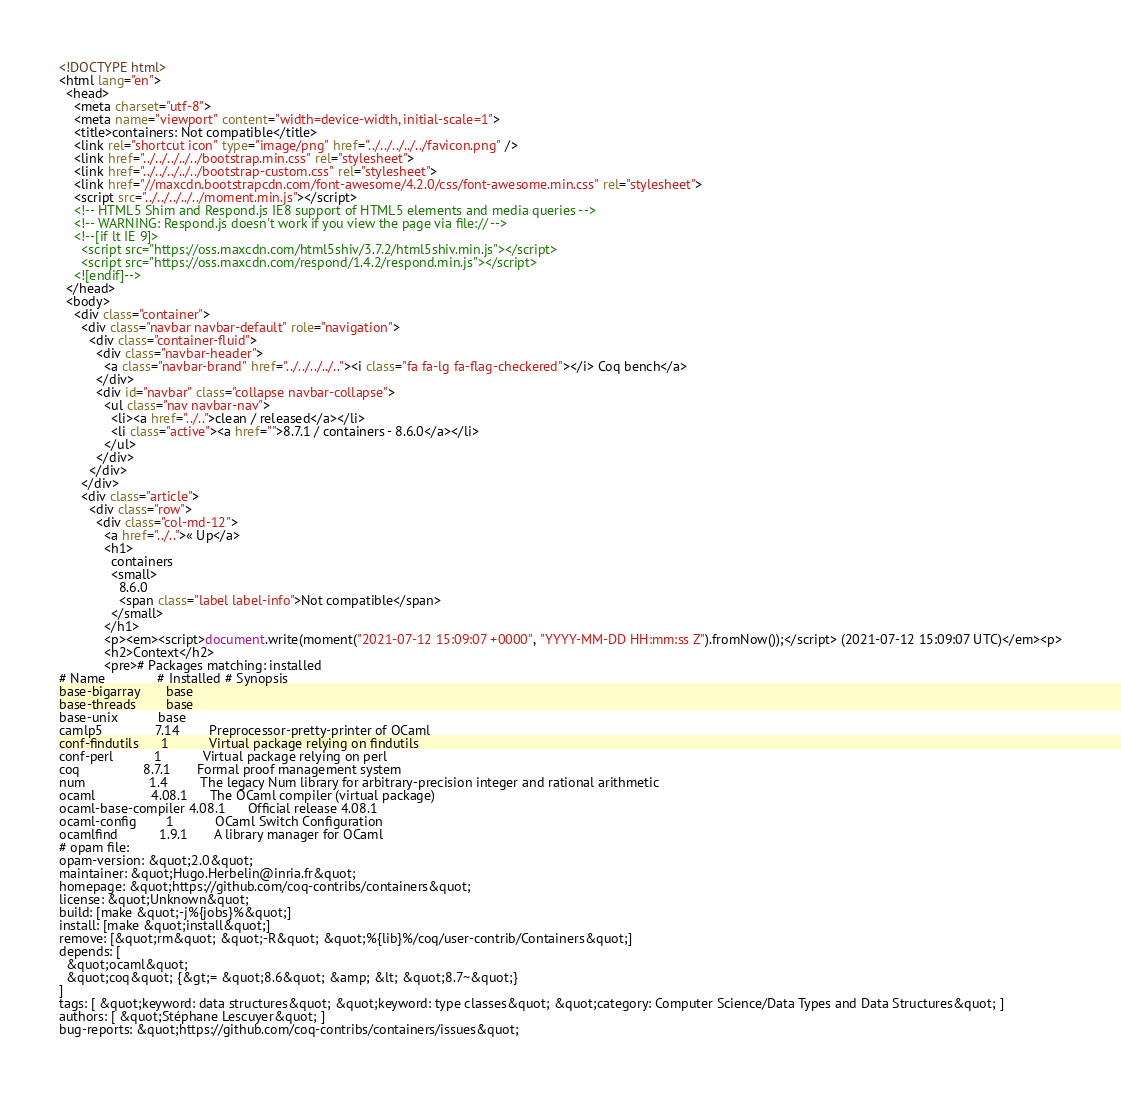<code> <loc_0><loc_0><loc_500><loc_500><_HTML_><!DOCTYPE html>
<html lang="en">
  <head>
    <meta charset="utf-8">
    <meta name="viewport" content="width=device-width, initial-scale=1">
    <title>containers: Not compatible</title>
    <link rel="shortcut icon" type="image/png" href="../../../../../favicon.png" />
    <link href="../../../../../bootstrap.min.css" rel="stylesheet">
    <link href="../../../../../bootstrap-custom.css" rel="stylesheet">
    <link href="//maxcdn.bootstrapcdn.com/font-awesome/4.2.0/css/font-awesome.min.css" rel="stylesheet">
    <script src="../../../../../moment.min.js"></script>
    <!-- HTML5 Shim and Respond.js IE8 support of HTML5 elements and media queries -->
    <!-- WARNING: Respond.js doesn't work if you view the page via file:// -->
    <!--[if lt IE 9]>
      <script src="https://oss.maxcdn.com/html5shiv/3.7.2/html5shiv.min.js"></script>
      <script src="https://oss.maxcdn.com/respond/1.4.2/respond.min.js"></script>
    <![endif]-->
  </head>
  <body>
    <div class="container">
      <div class="navbar navbar-default" role="navigation">
        <div class="container-fluid">
          <div class="navbar-header">
            <a class="navbar-brand" href="../../../../.."><i class="fa fa-lg fa-flag-checkered"></i> Coq bench</a>
          </div>
          <div id="navbar" class="collapse navbar-collapse">
            <ul class="nav navbar-nav">
              <li><a href="../..">clean / released</a></li>
              <li class="active"><a href="">8.7.1 / containers - 8.6.0</a></li>
            </ul>
          </div>
        </div>
      </div>
      <div class="article">
        <div class="row">
          <div class="col-md-12">
            <a href="../..">« Up</a>
            <h1>
              containers
              <small>
                8.6.0
                <span class="label label-info">Not compatible</span>
              </small>
            </h1>
            <p><em><script>document.write(moment("2021-07-12 15:09:07 +0000", "YYYY-MM-DD HH:mm:ss Z").fromNow());</script> (2021-07-12 15:09:07 UTC)</em><p>
            <h2>Context</h2>
            <pre># Packages matching: installed
# Name              # Installed # Synopsis
base-bigarray       base
base-threads        base
base-unix           base
camlp5              7.14        Preprocessor-pretty-printer of OCaml
conf-findutils      1           Virtual package relying on findutils
conf-perl           1           Virtual package relying on perl
coq                 8.7.1       Formal proof management system
num                 1.4         The legacy Num library for arbitrary-precision integer and rational arithmetic
ocaml               4.08.1      The OCaml compiler (virtual package)
ocaml-base-compiler 4.08.1      Official release 4.08.1
ocaml-config        1           OCaml Switch Configuration
ocamlfind           1.9.1       A library manager for OCaml
# opam file:
opam-version: &quot;2.0&quot;
maintainer: &quot;Hugo.Herbelin@inria.fr&quot;
homepage: &quot;https://github.com/coq-contribs/containers&quot;
license: &quot;Unknown&quot;
build: [make &quot;-j%{jobs}%&quot;]
install: [make &quot;install&quot;]
remove: [&quot;rm&quot; &quot;-R&quot; &quot;%{lib}%/coq/user-contrib/Containers&quot;]
depends: [
  &quot;ocaml&quot;
  &quot;coq&quot; {&gt;= &quot;8.6&quot; &amp; &lt; &quot;8.7~&quot;}
]
tags: [ &quot;keyword: data structures&quot; &quot;keyword: type classes&quot; &quot;category: Computer Science/Data Types and Data Structures&quot; ]
authors: [ &quot;Stéphane Lescuyer&quot; ]
bug-reports: &quot;https://github.com/coq-contribs/containers/issues&quot;</code> 